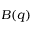Convert formula to latex. <formula><loc_0><loc_0><loc_500><loc_500>B ( q )</formula> 